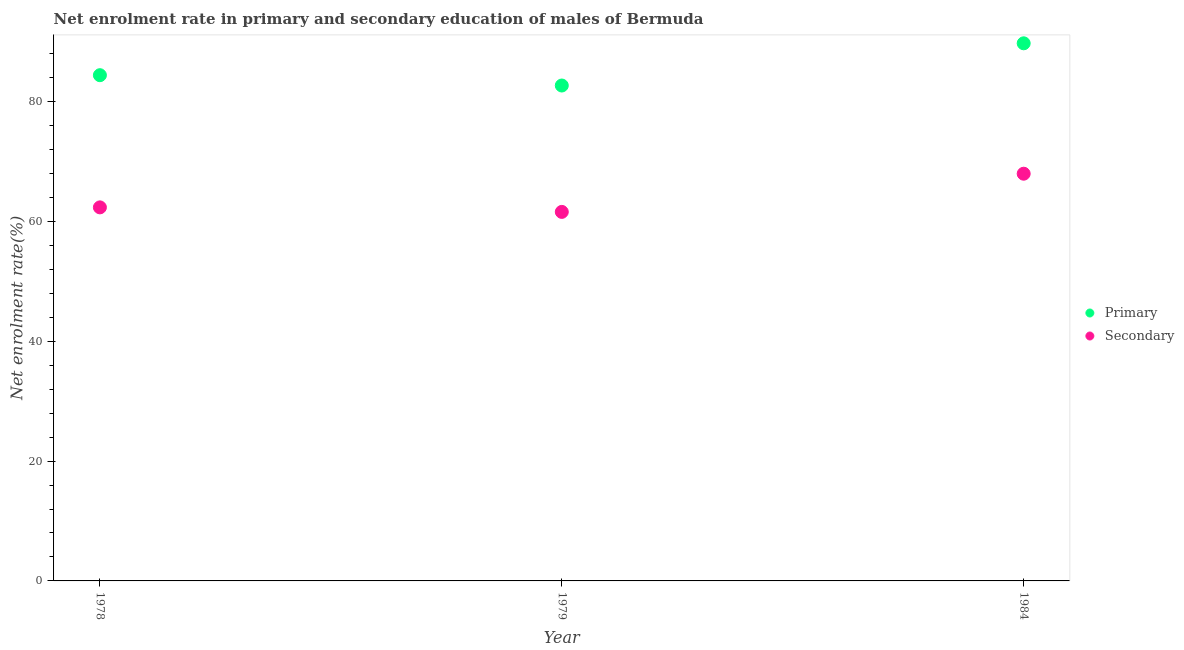How many different coloured dotlines are there?
Keep it short and to the point. 2. Is the number of dotlines equal to the number of legend labels?
Provide a short and direct response. Yes. What is the enrollment rate in secondary education in 1978?
Offer a terse response. 62.33. Across all years, what is the maximum enrollment rate in primary education?
Give a very brief answer. 89.7. Across all years, what is the minimum enrollment rate in primary education?
Your response must be concise. 82.66. In which year was the enrollment rate in primary education minimum?
Ensure brevity in your answer.  1979. What is the total enrollment rate in secondary education in the graph?
Give a very brief answer. 191.85. What is the difference between the enrollment rate in primary education in 1979 and that in 1984?
Ensure brevity in your answer.  -7.04. What is the difference between the enrollment rate in secondary education in 1978 and the enrollment rate in primary education in 1984?
Offer a terse response. -27.38. What is the average enrollment rate in secondary education per year?
Your response must be concise. 63.95. In the year 1978, what is the difference between the enrollment rate in secondary education and enrollment rate in primary education?
Your answer should be very brief. -22.06. What is the ratio of the enrollment rate in secondary education in 1978 to that in 1979?
Your answer should be compact. 1.01. What is the difference between the highest and the second highest enrollment rate in secondary education?
Your response must be concise. 5.62. What is the difference between the highest and the lowest enrollment rate in secondary education?
Offer a very short reply. 6.37. How many dotlines are there?
Provide a short and direct response. 2. How many years are there in the graph?
Provide a short and direct response. 3. What is the difference between two consecutive major ticks on the Y-axis?
Your answer should be very brief. 20. Does the graph contain any zero values?
Ensure brevity in your answer.  No. How are the legend labels stacked?
Your response must be concise. Vertical. What is the title of the graph?
Provide a succinct answer. Net enrolment rate in primary and secondary education of males of Bermuda. What is the label or title of the X-axis?
Make the answer very short. Year. What is the label or title of the Y-axis?
Provide a succinct answer. Net enrolment rate(%). What is the Net enrolment rate(%) in Primary in 1978?
Provide a succinct answer. 84.38. What is the Net enrolment rate(%) in Secondary in 1978?
Keep it short and to the point. 62.33. What is the Net enrolment rate(%) in Primary in 1979?
Your response must be concise. 82.66. What is the Net enrolment rate(%) of Secondary in 1979?
Offer a terse response. 61.57. What is the Net enrolment rate(%) of Primary in 1984?
Offer a terse response. 89.7. What is the Net enrolment rate(%) of Secondary in 1984?
Provide a succinct answer. 67.95. Across all years, what is the maximum Net enrolment rate(%) of Primary?
Offer a very short reply. 89.7. Across all years, what is the maximum Net enrolment rate(%) of Secondary?
Provide a short and direct response. 67.95. Across all years, what is the minimum Net enrolment rate(%) of Primary?
Ensure brevity in your answer.  82.66. Across all years, what is the minimum Net enrolment rate(%) in Secondary?
Provide a succinct answer. 61.57. What is the total Net enrolment rate(%) of Primary in the graph?
Your response must be concise. 256.75. What is the total Net enrolment rate(%) of Secondary in the graph?
Your answer should be very brief. 191.85. What is the difference between the Net enrolment rate(%) of Primary in 1978 and that in 1979?
Ensure brevity in your answer.  1.72. What is the difference between the Net enrolment rate(%) in Secondary in 1978 and that in 1979?
Give a very brief answer. 0.75. What is the difference between the Net enrolment rate(%) of Primary in 1978 and that in 1984?
Your answer should be very brief. -5.32. What is the difference between the Net enrolment rate(%) of Secondary in 1978 and that in 1984?
Give a very brief answer. -5.62. What is the difference between the Net enrolment rate(%) in Primary in 1979 and that in 1984?
Offer a very short reply. -7.04. What is the difference between the Net enrolment rate(%) of Secondary in 1979 and that in 1984?
Make the answer very short. -6.37. What is the difference between the Net enrolment rate(%) of Primary in 1978 and the Net enrolment rate(%) of Secondary in 1979?
Offer a very short reply. 22.81. What is the difference between the Net enrolment rate(%) in Primary in 1978 and the Net enrolment rate(%) in Secondary in 1984?
Provide a short and direct response. 16.44. What is the difference between the Net enrolment rate(%) in Primary in 1979 and the Net enrolment rate(%) in Secondary in 1984?
Offer a very short reply. 14.72. What is the average Net enrolment rate(%) in Primary per year?
Keep it short and to the point. 85.58. What is the average Net enrolment rate(%) in Secondary per year?
Offer a very short reply. 63.95. In the year 1978, what is the difference between the Net enrolment rate(%) in Primary and Net enrolment rate(%) in Secondary?
Your response must be concise. 22.06. In the year 1979, what is the difference between the Net enrolment rate(%) of Primary and Net enrolment rate(%) of Secondary?
Offer a very short reply. 21.09. In the year 1984, what is the difference between the Net enrolment rate(%) of Primary and Net enrolment rate(%) of Secondary?
Give a very brief answer. 21.76. What is the ratio of the Net enrolment rate(%) in Primary in 1978 to that in 1979?
Provide a succinct answer. 1.02. What is the ratio of the Net enrolment rate(%) in Secondary in 1978 to that in 1979?
Offer a terse response. 1.01. What is the ratio of the Net enrolment rate(%) of Primary in 1978 to that in 1984?
Make the answer very short. 0.94. What is the ratio of the Net enrolment rate(%) of Secondary in 1978 to that in 1984?
Provide a succinct answer. 0.92. What is the ratio of the Net enrolment rate(%) in Primary in 1979 to that in 1984?
Give a very brief answer. 0.92. What is the ratio of the Net enrolment rate(%) of Secondary in 1979 to that in 1984?
Offer a terse response. 0.91. What is the difference between the highest and the second highest Net enrolment rate(%) in Primary?
Ensure brevity in your answer.  5.32. What is the difference between the highest and the second highest Net enrolment rate(%) in Secondary?
Make the answer very short. 5.62. What is the difference between the highest and the lowest Net enrolment rate(%) in Primary?
Make the answer very short. 7.04. What is the difference between the highest and the lowest Net enrolment rate(%) in Secondary?
Provide a succinct answer. 6.37. 